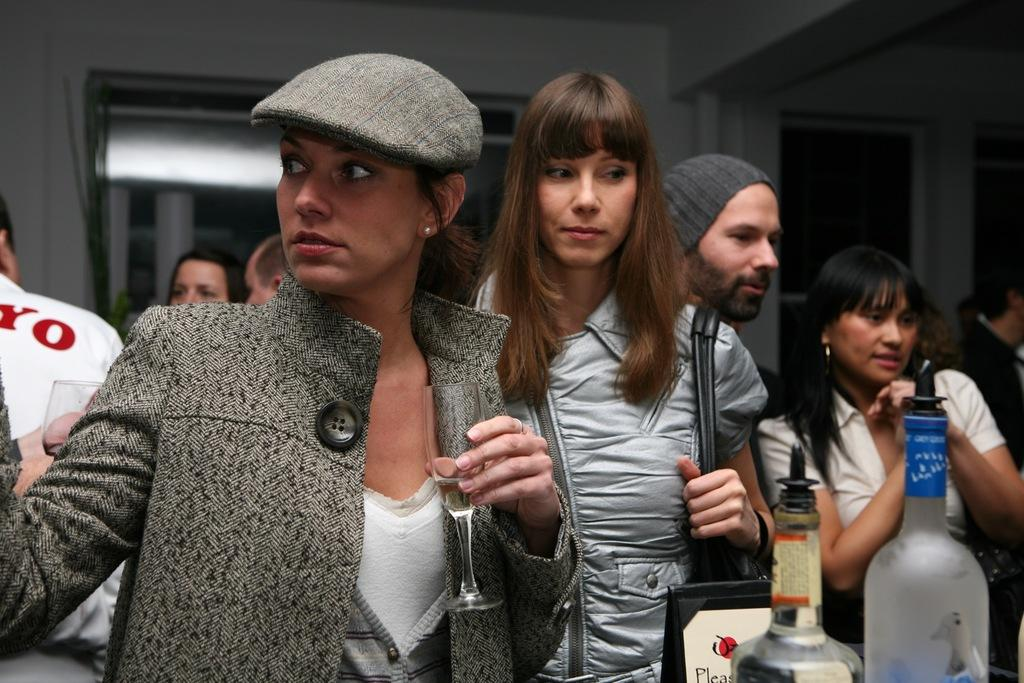What can be observed about the people in the image? There are people standing in the image. Can you describe the clothing or accessories of any of the people? One person is wearing a cap, and another person is wearing a bag. What is visible in the background of the image? There is a wall in the background of the image. What objects can be seen in addition to the people? There are bottles visible in the image. What type of treatment is being administered to the cat in the image? There is no cat present in the image, so no treatment can be observed. Can you describe the ear of the person wearing the cap in the image? The image does not provide a clear view of the person's ear, so it cannot be described in detail. 